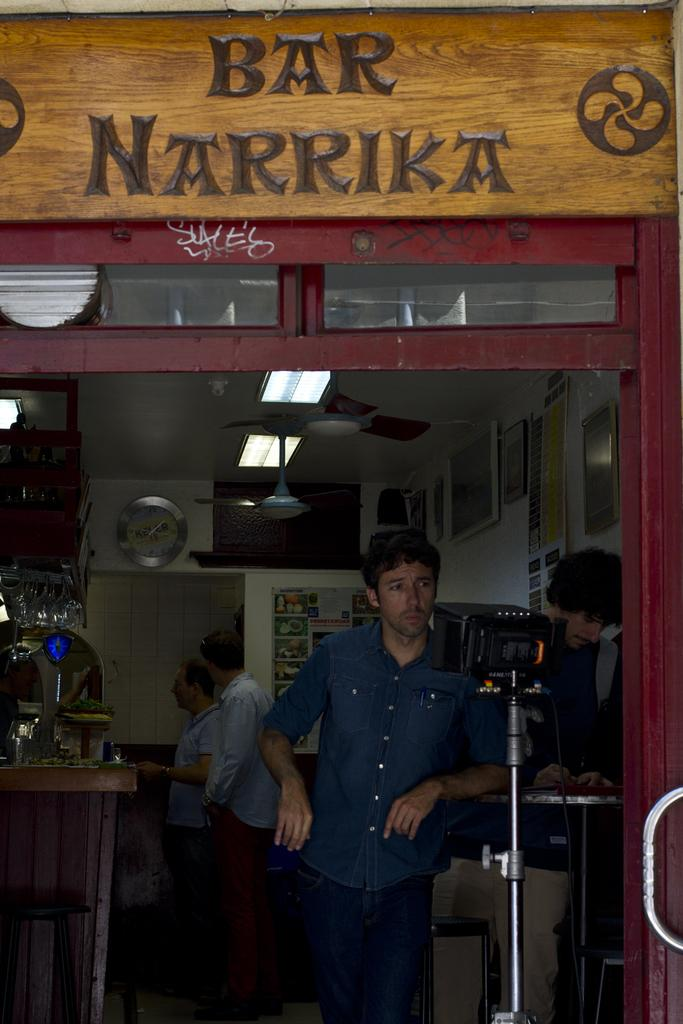<image>
Present a compact description of the photo's key features. A man standing underneath a sign that says Bar Narrika. 